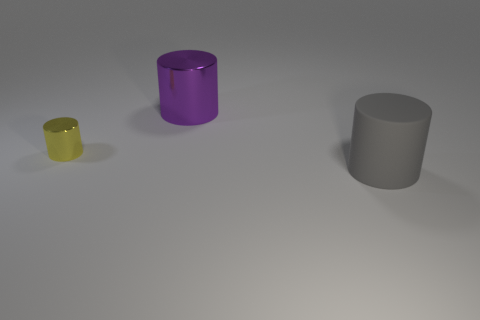What color is the thing that is to the right of the metal cylinder behind the metal cylinder in front of the large purple metallic cylinder?
Offer a very short reply. Gray. Is the number of tiny metallic cylinders behind the large purple cylinder the same as the number of rubber cylinders that are on the right side of the gray thing?
Provide a short and direct response. Yes. What shape is the purple object that is the same size as the gray matte cylinder?
Your response must be concise. Cylinder. Is there a small rubber block that has the same color as the big shiny cylinder?
Offer a very short reply. No. The big object on the left side of the gray cylinder has what shape?
Provide a short and direct response. Cylinder. The tiny shiny cylinder is what color?
Make the answer very short. Yellow. What color is the small cylinder that is the same material as the purple object?
Your answer should be very brief. Yellow. How many other large gray things are the same material as the gray thing?
Ensure brevity in your answer.  0. How many purple metallic objects are in front of the large purple metal thing?
Your response must be concise. 0. Do the cylinder that is left of the purple thing and the thing that is to the right of the purple metal object have the same material?
Your answer should be compact. No. 